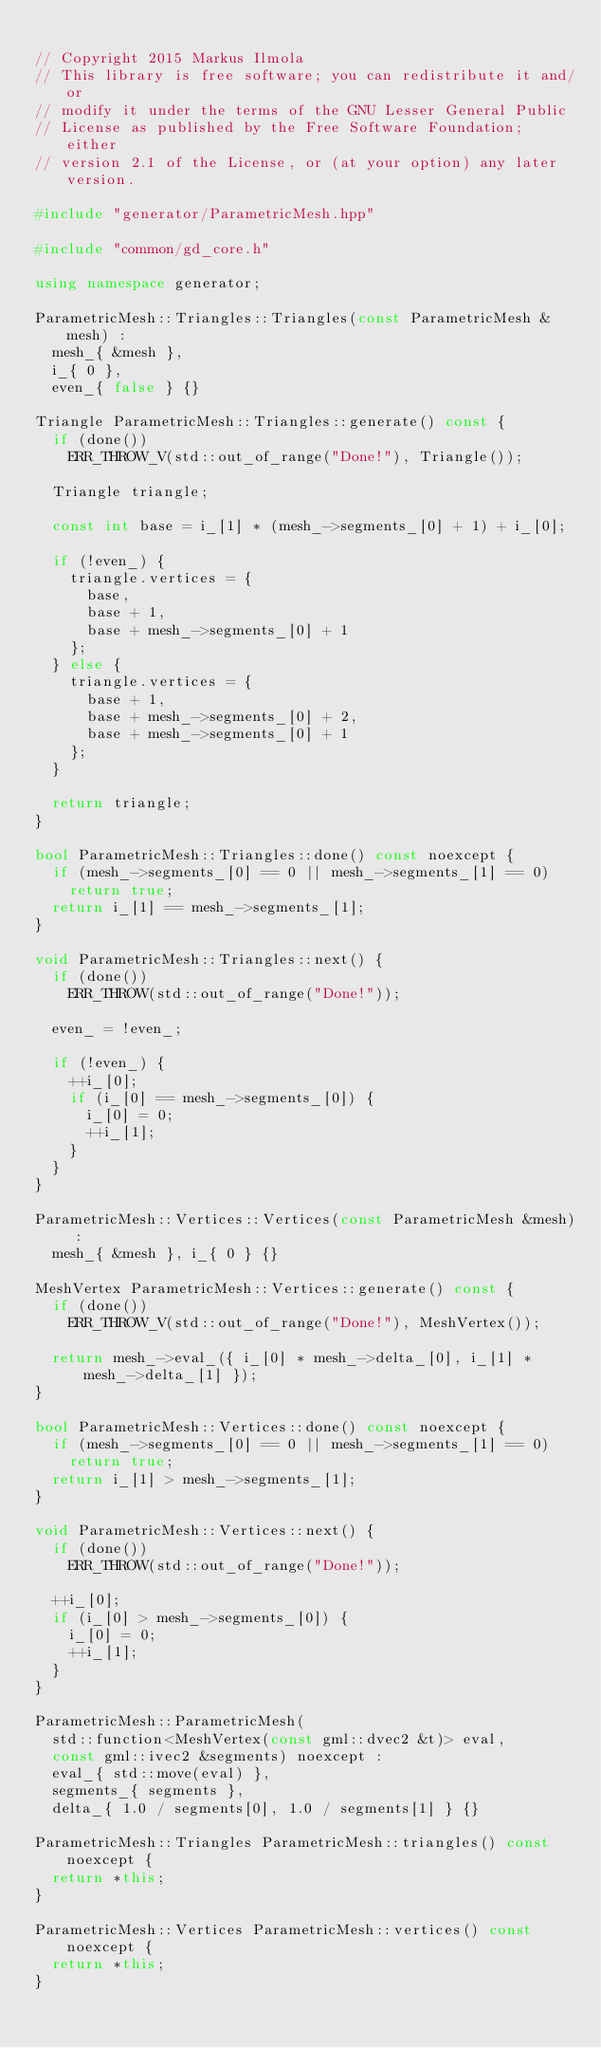<code> <loc_0><loc_0><loc_500><loc_500><_C++_>
// Copyright 2015 Markus Ilmola
// This library is free software; you can redistribute it and/or
// modify it under the terms of the GNU Lesser General Public
// License as published by the Free Software Foundation; either
// version 2.1 of the License, or (at your option) any later version.

#include "generator/ParametricMesh.hpp"

#include "common/gd_core.h"

using namespace generator;

ParametricMesh::Triangles::Triangles(const ParametricMesh &mesh) :
	mesh_{ &mesh },
	i_{ 0 },
	even_{ false } {}

Triangle ParametricMesh::Triangles::generate() const {
	if (done())
		ERR_THROW_V(std::out_of_range("Done!"), Triangle());

	Triangle triangle;

	const int base = i_[1] * (mesh_->segments_[0] + 1) + i_[0];

	if (!even_) {
		triangle.vertices = {
			base,
			base + 1,
			base + mesh_->segments_[0] + 1
		};
	} else {
		triangle.vertices = {
			base + 1,
			base + mesh_->segments_[0] + 2,
			base + mesh_->segments_[0] + 1
		};
	}

	return triangle;
}

bool ParametricMesh::Triangles::done() const noexcept {
	if (mesh_->segments_[0] == 0 || mesh_->segments_[1] == 0)
		return true;
	return i_[1] == mesh_->segments_[1];
}

void ParametricMesh::Triangles::next() {
	if (done())
		ERR_THROW(std::out_of_range("Done!"));

	even_ = !even_;

	if (!even_) {
		++i_[0];
		if (i_[0] == mesh_->segments_[0]) {
			i_[0] = 0;
			++i_[1];
		}
	}
}

ParametricMesh::Vertices::Vertices(const ParametricMesh &mesh) :
	mesh_{ &mesh }, i_{ 0 } {}

MeshVertex ParametricMesh::Vertices::generate() const {
	if (done())
		ERR_THROW_V(std::out_of_range("Done!"), MeshVertex());

	return mesh_->eval_({ i_[0] * mesh_->delta_[0], i_[1] * mesh_->delta_[1] });
}

bool ParametricMesh::Vertices::done() const noexcept {
	if (mesh_->segments_[0] == 0 || mesh_->segments_[1] == 0)
		return true;
	return i_[1] > mesh_->segments_[1];
}

void ParametricMesh::Vertices::next() {
	if (done())
		ERR_THROW(std::out_of_range("Done!"));

	++i_[0];
	if (i_[0] > mesh_->segments_[0]) {
		i_[0] = 0;
		++i_[1];
	}
}

ParametricMesh::ParametricMesh(
	std::function<MeshVertex(const gml::dvec2 &t)> eval,
	const gml::ivec2 &segments) noexcept :
	eval_{ std::move(eval) },
	segments_{ segments },
	delta_{ 1.0 / segments[0], 1.0 / segments[1] } {}

ParametricMesh::Triangles ParametricMesh::triangles() const noexcept {
	return *this;
}

ParametricMesh::Vertices ParametricMesh::vertices() const noexcept {
	return *this;
}
</code> 